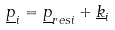Convert formula to latex. <formula><loc_0><loc_0><loc_500><loc_500>\underline { p } _ { i } = \underline { p } _ { r e s i } + \underline { k } _ { i }</formula> 